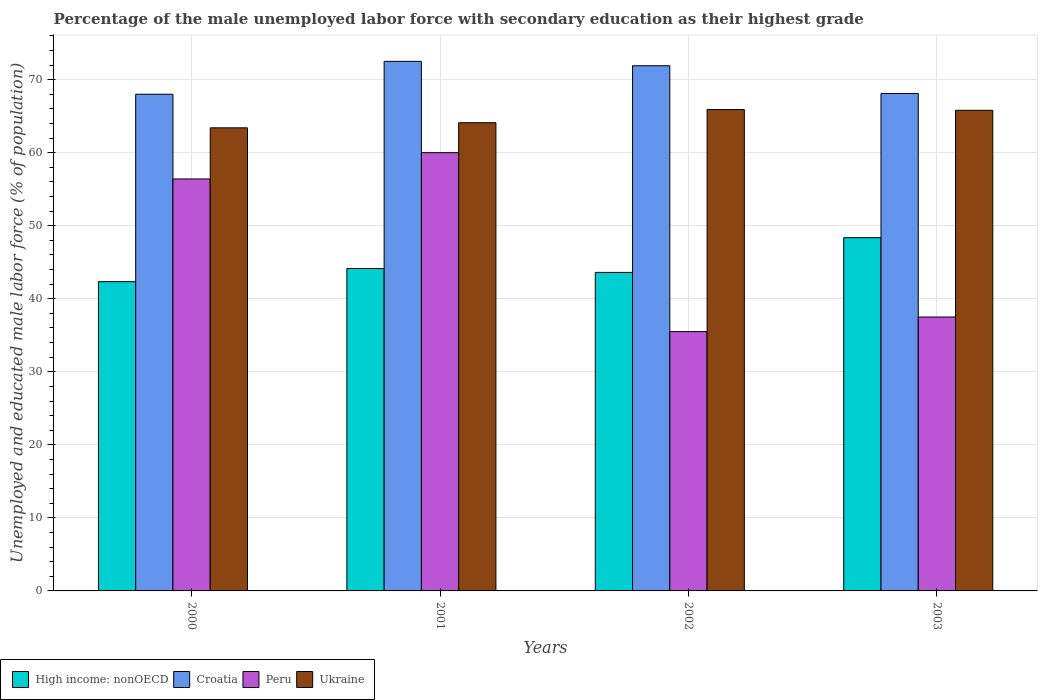How many groups of bars are there?
Offer a terse response. 4. Are the number of bars per tick equal to the number of legend labels?
Ensure brevity in your answer.  Yes. Are the number of bars on each tick of the X-axis equal?
Your response must be concise. Yes. How many bars are there on the 2nd tick from the left?
Offer a very short reply. 4. In how many cases, is the number of bars for a given year not equal to the number of legend labels?
Your answer should be compact. 0. What is the percentage of the unemployed male labor force with secondary education in Ukraine in 2002?
Offer a terse response. 65.9. Across all years, what is the maximum percentage of the unemployed male labor force with secondary education in Ukraine?
Make the answer very short. 65.9. Across all years, what is the minimum percentage of the unemployed male labor force with secondary education in High income: nonOECD?
Offer a very short reply. 42.34. What is the total percentage of the unemployed male labor force with secondary education in Croatia in the graph?
Ensure brevity in your answer.  280.5. What is the difference between the percentage of the unemployed male labor force with secondary education in Croatia in 2000 and that in 2003?
Offer a terse response. -0.1. What is the difference between the percentage of the unemployed male labor force with secondary education in Peru in 2001 and the percentage of the unemployed male labor force with secondary education in High income: nonOECD in 2002?
Provide a short and direct response. 16.39. What is the average percentage of the unemployed male labor force with secondary education in Ukraine per year?
Ensure brevity in your answer.  64.8. In the year 2003, what is the difference between the percentage of the unemployed male labor force with secondary education in Peru and percentage of the unemployed male labor force with secondary education in High income: nonOECD?
Make the answer very short. -10.86. In how many years, is the percentage of the unemployed male labor force with secondary education in High income: nonOECD greater than 48 %?
Give a very brief answer. 1. What is the ratio of the percentage of the unemployed male labor force with secondary education in Peru in 2000 to that in 2002?
Offer a terse response. 1.59. What is the difference between the highest and the second highest percentage of the unemployed male labor force with secondary education in Ukraine?
Make the answer very short. 0.1. In how many years, is the percentage of the unemployed male labor force with secondary education in High income: nonOECD greater than the average percentage of the unemployed male labor force with secondary education in High income: nonOECD taken over all years?
Give a very brief answer. 1. Is the sum of the percentage of the unemployed male labor force with secondary education in Croatia in 2002 and 2003 greater than the maximum percentage of the unemployed male labor force with secondary education in High income: nonOECD across all years?
Ensure brevity in your answer.  Yes. Is it the case that in every year, the sum of the percentage of the unemployed male labor force with secondary education in High income: nonOECD and percentage of the unemployed male labor force with secondary education in Peru is greater than the sum of percentage of the unemployed male labor force with secondary education in Croatia and percentage of the unemployed male labor force with secondary education in Ukraine?
Your answer should be very brief. No. What does the 2nd bar from the left in 2002 represents?
Your answer should be compact. Croatia. What does the 3rd bar from the right in 2002 represents?
Give a very brief answer. Croatia. Is it the case that in every year, the sum of the percentage of the unemployed male labor force with secondary education in High income: nonOECD and percentage of the unemployed male labor force with secondary education in Ukraine is greater than the percentage of the unemployed male labor force with secondary education in Peru?
Make the answer very short. Yes. How many bars are there?
Your answer should be compact. 16. What is the difference between two consecutive major ticks on the Y-axis?
Provide a short and direct response. 10. Does the graph contain grids?
Offer a terse response. Yes. How many legend labels are there?
Your answer should be compact. 4. What is the title of the graph?
Ensure brevity in your answer.  Percentage of the male unemployed labor force with secondary education as their highest grade. What is the label or title of the X-axis?
Keep it short and to the point. Years. What is the label or title of the Y-axis?
Offer a very short reply. Unemployed and educated male labor force (% of population). What is the Unemployed and educated male labor force (% of population) in High income: nonOECD in 2000?
Ensure brevity in your answer.  42.34. What is the Unemployed and educated male labor force (% of population) of Croatia in 2000?
Your answer should be compact. 68. What is the Unemployed and educated male labor force (% of population) in Peru in 2000?
Keep it short and to the point. 56.4. What is the Unemployed and educated male labor force (% of population) of Ukraine in 2000?
Offer a very short reply. 63.4. What is the Unemployed and educated male labor force (% of population) in High income: nonOECD in 2001?
Make the answer very short. 44.14. What is the Unemployed and educated male labor force (% of population) of Croatia in 2001?
Offer a very short reply. 72.5. What is the Unemployed and educated male labor force (% of population) of Peru in 2001?
Your answer should be compact. 60. What is the Unemployed and educated male labor force (% of population) of Ukraine in 2001?
Your response must be concise. 64.1. What is the Unemployed and educated male labor force (% of population) in High income: nonOECD in 2002?
Provide a succinct answer. 43.61. What is the Unemployed and educated male labor force (% of population) of Croatia in 2002?
Give a very brief answer. 71.9. What is the Unemployed and educated male labor force (% of population) in Peru in 2002?
Offer a very short reply. 35.5. What is the Unemployed and educated male labor force (% of population) of Ukraine in 2002?
Provide a short and direct response. 65.9. What is the Unemployed and educated male labor force (% of population) in High income: nonOECD in 2003?
Offer a terse response. 48.36. What is the Unemployed and educated male labor force (% of population) in Croatia in 2003?
Your answer should be compact. 68.1. What is the Unemployed and educated male labor force (% of population) in Peru in 2003?
Offer a very short reply. 37.5. What is the Unemployed and educated male labor force (% of population) in Ukraine in 2003?
Offer a terse response. 65.8. Across all years, what is the maximum Unemployed and educated male labor force (% of population) of High income: nonOECD?
Your answer should be very brief. 48.36. Across all years, what is the maximum Unemployed and educated male labor force (% of population) of Croatia?
Give a very brief answer. 72.5. Across all years, what is the maximum Unemployed and educated male labor force (% of population) of Ukraine?
Provide a succinct answer. 65.9. Across all years, what is the minimum Unemployed and educated male labor force (% of population) in High income: nonOECD?
Your response must be concise. 42.34. Across all years, what is the minimum Unemployed and educated male labor force (% of population) of Croatia?
Provide a short and direct response. 68. Across all years, what is the minimum Unemployed and educated male labor force (% of population) of Peru?
Provide a short and direct response. 35.5. Across all years, what is the minimum Unemployed and educated male labor force (% of population) in Ukraine?
Your answer should be compact. 63.4. What is the total Unemployed and educated male labor force (% of population) in High income: nonOECD in the graph?
Make the answer very short. 178.45. What is the total Unemployed and educated male labor force (% of population) of Croatia in the graph?
Provide a short and direct response. 280.5. What is the total Unemployed and educated male labor force (% of population) of Peru in the graph?
Provide a succinct answer. 189.4. What is the total Unemployed and educated male labor force (% of population) of Ukraine in the graph?
Provide a succinct answer. 259.2. What is the difference between the Unemployed and educated male labor force (% of population) of High income: nonOECD in 2000 and that in 2001?
Ensure brevity in your answer.  -1.8. What is the difference between the Unemployed and educated male labor force (% of population) in Croatia in 2000 and that in 2001?
Make the answer very short. -4.5. What is the difference between the Unemployed and educated male labor force (% of population) of Ukraine in 2000 and that in 2001?
Provide a short and direct response. -0.7. What is the difference between the Unemployed and educated male labor force (% of population) in High income: nonOECD in 2000 and that in 2002?
Make the answer very short. -1.26. What is the difference between the Unemployed and educated male labor force (% of population) in Croatia in 2000 and that in 2002?
Give a very brief answer. -3.9. What is the difference between the Unemployed and educated male labor force (% of population) of Peru in 2000 and that in 2002?
Keep it short and to the point. 20.9. What is the difference between the Unemployed and educated male labor force (% of population) of Ukraine in 2000 and that in 2002?
Make the answer very short. -2.5. What is the difference between the Unemployed and educated male labor force (% of population) of High income: nonOECD in 2000 and that in 2003?
Your answer should be compact. -6.02. What is the difference between the Unemployed and educated male labor force (% of population) in Croatia in 2000 and that in 2003?
Provide a succinct answer. -0.1. What is the difference between the Unemployed and educated male labor force (% of population) of Ukraine in 2000 and that in 2003?
Your answer should be very brief. -2.4. What is the difference between the Unemployed and educated male labor force (% of population) in High income: nonOECD in 2001 and that in 2002?
Make the answer very short. 0.54. What is the difference between the Unemployed and educated male labor force (% of population) in Peru in 2001 and that in 2002?
Your answer should be very brief. 24.5. What is the difference between the Unemployed and educated male labor force (% of population) of High income: nonOECD in 2001 and that in 2003?
Offer a very short reply. -4.21. What is the difference between the Unemployed and educated male labor force (% of population) in Peru in 2001 and that in 2003?
Your response must be concise. 22.5. What is the difference between the Unemployed and educated male labor force (% of population) of Ukraine in 2001 and that in 2003?
Offer a terse response. -1.7. What is the difference between the Unemployed and educated male labor force (% of population) in High income: nonOECD in 2002 and that in 2003?
Offer a very short reply. -4.75. What is the difference between the Unemployed and educated male labor force (% of population) of Ukraine in 2002 and that in 2003?
Keep it short and to the point. 0.1. What is the difference between the Unemployed and educated male labor force (% of population) in High income: nonOECD in 2000 and the Unemployed and educated male labor force (% of population) in Croatia in 2001?
Give a very brief answer. -30.16. What is the difference between the Unemployed and educated male labor force (% of population) in High income: nonOECD in 2000 and the Unemployed and educated male labor force (% of population) in Peru in 2001?
Give a very brief answer. -17.66. What is the difference between the Unemployed and educated male labor force (% of population) in High income: nonOECD in 2000 and the Unemployed and educated male labor force (% of population) in Ukraine in 2001?
Offer a terse response. -21.76. What is the difference between the Unemployed and educated male labor force (% of population) of Croatia in 2000 and the Unemployed and educated male labor force (% of population) of Peru in 2001?
Ensure brevity in your answer.  8. What is the difference between the Unemployed and educated male labor force (% of population) in Croatia in 2000 and the Unemployed and educated male labor force (% of population) in Ukraine in 2001?
Give a very brief answer. 3.9. What is the difference between the Unemployed and educated male labor force (% of population) in Peru in 2000 and the Unemployed and educated male labor force (% of population) in Ukraine in 2001?
Provide a short and direct response. -7.7. What is the difference between the Unemployed and educated male labor force (% of population) in High income: nonOECD in 2000 and the Unemployed and educated male labor force (% of population) in Croatia in 2002?
Make the answer very short. -29.56. What is the difference between the Unemployed and educated male labor force (% of population) of High income: nonOECD in 2000 and the Unemployed and educated male labor force (% of population) of Peru in 2002?
Make the answer very short. 6.84. What is the difference between the Unemployed and educated male labor force (% of population) of High income: nonOECD in 2000 and the Unemployed and educated male labor force (% of population) of Ukraine in 2002?
Your answer should be very brief. -23.56. What is the difference between the Unemployed and educated male labor force (% of population) of Croatia in 2000 and the Unemployed and educated male labor force (% of population) of Peru in 2002?
Your answer should be compact. 32.5. What is the difference between the Unemployed and educated male labor force (% of population) of Peru in 2000 and the Unemployed and educated male labor force (% of population) of Ukraine in 2002?
Your answer should be compact. -9.5. What is the difference between the Unemployed and educated male labor force (% of population) in High income: nonOECD in 2000 and the Unemployed and educated male labor force (% of population) in Croatia in 2003?
Provide a succinct answer. -25.76. What is the difference between the Unemployed and educated male labor force (% of population) of High income: nonOECD in 2000 and the Unemployed and educated male labor force (% of population) of Peru in 2003?
Provide a short and direct response. 4.84. What is the difference between the Unemployed and educated male labor force (% of population) in High income: nonOECD in 2000 and the Unemployed and educated male labor force (% of population) in Ukraine in 2003?
Provide a short and direct response. -23.46. What is the difference between the Unemployed and educated male labor force (% of population) in Croatia in 2000 and the Unemployed and educated male labor force (% of population) in Peru in 2003?
Your response must be concise. 30.5. What is the difference between the Unemployed and educated male labor force (% of population) of Croatia in 2000 and the Unemployed and educated male labor force (% of population) of Ukraine in 2003?
Provide a succinct answer. 2.2. What is the difference between the Unemployed and educated male labor force (% of population) in Peru in 2000 and the Unemployed and educated male labor force (% of population) in Ukraine in 2003?
Make the answer very short. -9.4. What is the difference between the Unemployed and educated male labor force (% of population) of High income: nonOECD in 2001 and the Unemployed and educated male labor force (% of population) of Croatia in 2002?
Keep it short and to the point. -27.76. What is the difference between the Unemployed and educated male labor force (% of population) of High income: nonOECD in 2001 and the Unemployed and educated male labor force (% of population) of Peru in 2002?
Your answer should be compact. 8.64. What is the difference between the Unemployed and educated male labor force (% of population) in High income: nonOECD in 2001 and the Unemployed and educated male labor force (% of population) in Ukraine in 2002?
Offer a terse response. -21.76. What is the difference between the Unemployed and educated male labor force (% of population) in Croatia in 2001 and the Unemployed and educated male labor force (% of population) in Peru in 2002?
Provide a succinct answer. 37. What is the difference between the Unemployed and educated male labor force (% of population) in High income: nonOECD in 2001 and the Unemployed and educated male labor force (% of population) in Croatia in 2003?
Make the answer very short. -23.96. What is the difference between the Unemployed and educated male labor force (% of population) in High income: nonOECD in 2001 and the Unemployed and educated male labor force (% of population) in Peru in 2003?
Keep it short and to the point. 6.64. What is the difference between the Unemployed and educated male labor force (% of population) of High income: nonOECD in 2001 and the Unemployed and educated male labor force (% of population) of Ukraine in 2003?
Provide a succinct answer. -21.66. What is the difference between the Unemployed and educated male labor force (% of population) in Peru in 2001 and the Unemployed and educated male labor force (% of population) in Ukraine in 2003?
Your answer should be compact. -5.8. What is the difference between the Unemployed and educated male labor force (% of population) of High income: nonOECD in 2002 and the Unemployed and educated male labor force (% of population) of Croatia in 2003?
Provide a succinct answer. -24.49. What is the difference between the Unemployed and educated male labor force (% of population) of High income: nonOECD in 2002 and the Unemployed and educated male labor force (% of population) of Peru in 2003?
Offer a very short reply. 6.11. What is the difference between the Unemployed and educated male labor force (% of population) of High income: nonOECD in 2002 and the Unemployed and educated male labor force (% of population) of Ukraine in 2003?
Offer a terse response. -22.19. What is the difference between the Unemployed and educated male labor force (% of population) in Croatia in 2002 and the Unemployed and educated male labor force (% of population) in Peru in 2003?
Ensure brevity in your answer.  34.4. What is the difference between the Unemployed and educated male labor force (% of population) in Croatia in 2002 and the Unemployed and educated male labor force (% of population) in Ukraine in 2003?
Offer a terse response. 6.1. What is the difference between the Unemployed and educated male labor force (% of population) in Peru in 2002 and the Unemployed and educated male labor force (% of population) in Ukraine in 2003?
Your answer should be compact. -30.3. What is the average Unemployed and educated male labor force (% of population) of High income: nonOECD per year?
Your answer should be very brief. 44.61. What is the average Unemployed and educated male labor force (% of population) in Croatia per year?
Your response must be concise. 70.12. What is the average Unemployed and educated male labor force (% of population) in Peru per year?
Your answer should be very brief. 47.35. What is the average Unemployed and educated male labor force (% of population) in Ukraine per year?
Ensure brevity in your answer.  64.8. In the year 2000, what is the difference between the Unemployed and educated male labor force (% of population) of High income: nonOECD and Unemployed and educated male labor force (% of population) of Croatia?
Ensure brevity in your answer.  -25.66. In the year 2000, what is the difference between the Unemployed and educated male labor force (% of population) in High income: nonOECD and Unemployed and educated male labor force (% of population) in Peru?
Your answer should be very brief. -14.06. In the year 2000, what is the difference between the Unemployed and educated male labor force (% of population) of High income: nonOECD and Unemployed and educated male labor force (% of population) of Ukraine?
Offer a very short reply. -21.06. In the year 2000, what is the difference between the Unemployed and educated male labor force (% of population) of Croatia and Unemployed and educated male labor force (% of population) of Peru?
Make the answer very short. 11.6. In the year 2001, what is the difference between the Unemployed and educated male labor force (% of population) of High income: nonOECD and Unemployed and educated male labor force (% of population) of Croatia?
Ensure brevity in your answer.  -28.36. In the year 2001, what is the difference between the Unemployed and educated male labor force (% of population) in High income: nonOECD and Unemployed and educated male labor force (% of population) in Peru?
Ensure brevity in your answer.  -15.86. In the year 2001, what is the difference between the Unemployed and educated male labor force (% of population) in High income: nonOECD and Unemployed and educated male labor force (% of population) in Ukraine?
Provide a short and direct response. -19.96. In the year 2001, what is the difference between the Unemployed and educated male labor force (% of population) of Peru and Unemployed and educated male labor force (% of population) of Ukraine?
Ensure brevity in your answer.  -4.1. In the year 2002, what is the difference between the Unemployed and educated male labor force (% of population) in High income: nonOECD and Unemployed and educated male labor force (% of population) in Croatia?
Offer a terse response. -28.29. In the year 2002, what is the difference between the Unemployed and educated male labor force (% of population) in High income: nonOECD and Unemployed and educated male labor force (% of population) in Peru?
Give a very brief answer. 8.11. In the year 2002, what is the difference between the Unemployed and educated male labor force (% of population) in High income: nonOECD and Unemployed and educated male labor force (% of population) in Ukraine?
Keep it short and to the point. -22.29. In the year 2002, what is the difference between the Unemployed and educated male labor force (% of population) in Croatia and Unemployed and educated male labor force (% of population) in Peru?
Your answer should be compact. 36.4. In the year 2002, what is the difference between the Unemployed and educated male labor force (% of population) of Croatia and Unemployed and educated male labor force (% of population) of Ukraine?
Provide a short and direct response. 6. In the year 2002, what is the difference between the Unemployed and educated male labor force (% of population) in Peru and Unemployed and educated male labor force (% of population) in Ukraine?
Provide a succinct answer. -30.4. In the year 2003, what is the difference between the Unemployed and educated male labor force (% of population) of High income: nonOECD and Unemployed and educated male labor force (% of population) of Croatia?
Offer a terse response. -19.74. In the year 2003, what is the difference between the Unemployed and educated male labor force (% of population) in High income: nonOECD and Unemployed and educated male labor force (% of population) in Peru?
Provide a short and direct response. 10.86. In the year 2003, what is the difference between the Unemployed and educated male labor force (% of population) of High income: nonOECD and Unemployed and educated male labor force (% of population) of Ukraine?
Your answer should be compact. -17.44. In the year 2003, what is the difference between the Unemployed and educated male labor force (% of population) of Croatia and Unemployed and educated male labor force (% of population) of Peru?
Provide a succinct answer. 30.6. In the year 2003, what is the difference between the Unemployed and educated male labor force (% of population) in Croatia and Unemployed and educated male labor force (% of population) in Ukraine?
Offer a very short reply. 2.3. In the year 2003, what is the difference between the Unemployed and educated male labor force (% of population) of Peru and Unemployed and educated male labor force (% of population) of Ukraine?
Your response must be concise. -28.3. What is the ratio of the Unemployed and educated male labor force (% of population) of High income: nonOECD in 2000 to that in 2001?
Provide a succinct answer. 0.96. What is the ratio of the Unemployed and educated male labor force (% of population) of Croatia in 2000 to that in 2001?
Provide a short and direct response. 0.94. What is the ratio of the Unemployed and educated male labor force (% of population) in Ukraine in 2000 to that in 2001?
Your response must be concise. 0.99. What is the ratio of the Unemployed and educated male labor force (% of population) in Croatia in 2000 to that in 2002?
Provide a short and direct response. 0.95. What is the ratio of the Unemployed and educated male labor force (% of population) in Peru in 2000 to that in 2002?
Your answer should be compact. 1.59. What is the ratio of the Unemployed and educated male labor force (% of population) of Ukraine in 2000 to that in 2002?
Offer a terse response. 0.96. What is the ratio of the Unemployed and educated male labor force (% of population) in High income: nonOECD in 2000 to that in 2003?
Offer a very short reply. 0.88. What is the ratio of the Unemployed and educated male labor force (% of population) in Croatia in 2000 to that in 2003?
Your answer should be compact. 1. What is the ratio of the Unemployed and educated male labor force (% of population) in Peru in 2000 to that in 2003?
Ensure brevity in your answer.  1.5. What is the ratio of the Unemployed and educated male labor force (% of population) in Ukraine in 2000 to that in 2003?
Make the answer very short. 0.96. What is the ratio of the Unemployed and educated male labor force (% of population) of High income: nonOECD in 2001 to that in 2002?
Make the answer very short. 1.01. What is the ratio of the Unemployed and educated male labor force (% of population) in Croatia in 2001 to that in 2002?
Provide a succinct answer. 1.01. What is the ratio of the Unemployed and educated male labor force (% of population) of Peru in 2001 to that in 2002?
Provide a succinct answer. 1.69. What is the ratio of the Unemployed and educated male labor force (% of population) of Ukraine in 2001 to that in 2002?
Provide a short and direct response. 0.97. What is the ratio of the Unemployed and educated male labor force (% of population) of High income: nonOECD in 2001 to that in 2003?
Give a very brief answer. 0.91. What is the ratio of the Unemployed and educated male labor force (% of population) of Croatia in 2001 to that in 2003?
Make the answer very short. 1.06. What is the ratio of the Unemployed and educated male labor force (% of population) in Ukraine in 2001 to that in 2003?
Keep it short and to the point. 0.97. What is the ratio of the Unemployed and educated male labor force (% of population) of High income: nonOECD in 2002 to that in 2003?
Your answer should be compact. 0.9. What is the ratio of the Unemployed and educated male labor force (% of population) of Croatia in 2002 to that in 2003?
Your answer should be compact. 1.06. What is the ratio of the Unemployed and educated male labor force (% of population) in Peru in 2002 to that in 2003?
Provide a succinct answer. 0.95. What is the difference between the highest and the second highest Unemployed and educated male labor force (% of population) in High income: nonOECD?
Your answer should be compact. 4.21. What is the difference between the highest and the second highest Unemployed and educated male labor force (% of population) of Ukraine?
Keep it short and to the point. 0.1. What is the difference between the highest and the lowest Unemployed and educated male labor force (% of population) in High income: nonOECD?
Your answer should be compact. 6.02. What is the difference between the highest and the lowest Unemployed and educated male labor force (% of population) in Peru?
Your answer should be very brief. 24.5. 